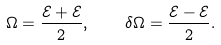Convert formula to latex. <formula><loc_0><loc_0><loc_500><loc_500>\Omega = \frac { \mathcal { E } _ { } + \mathcal { E } _ { } } { 2 } , \quad \delta \Omega = \frac { \mathcal { E } _ { } - \mathcal { E } _ { } } { 2 } .</formula> 